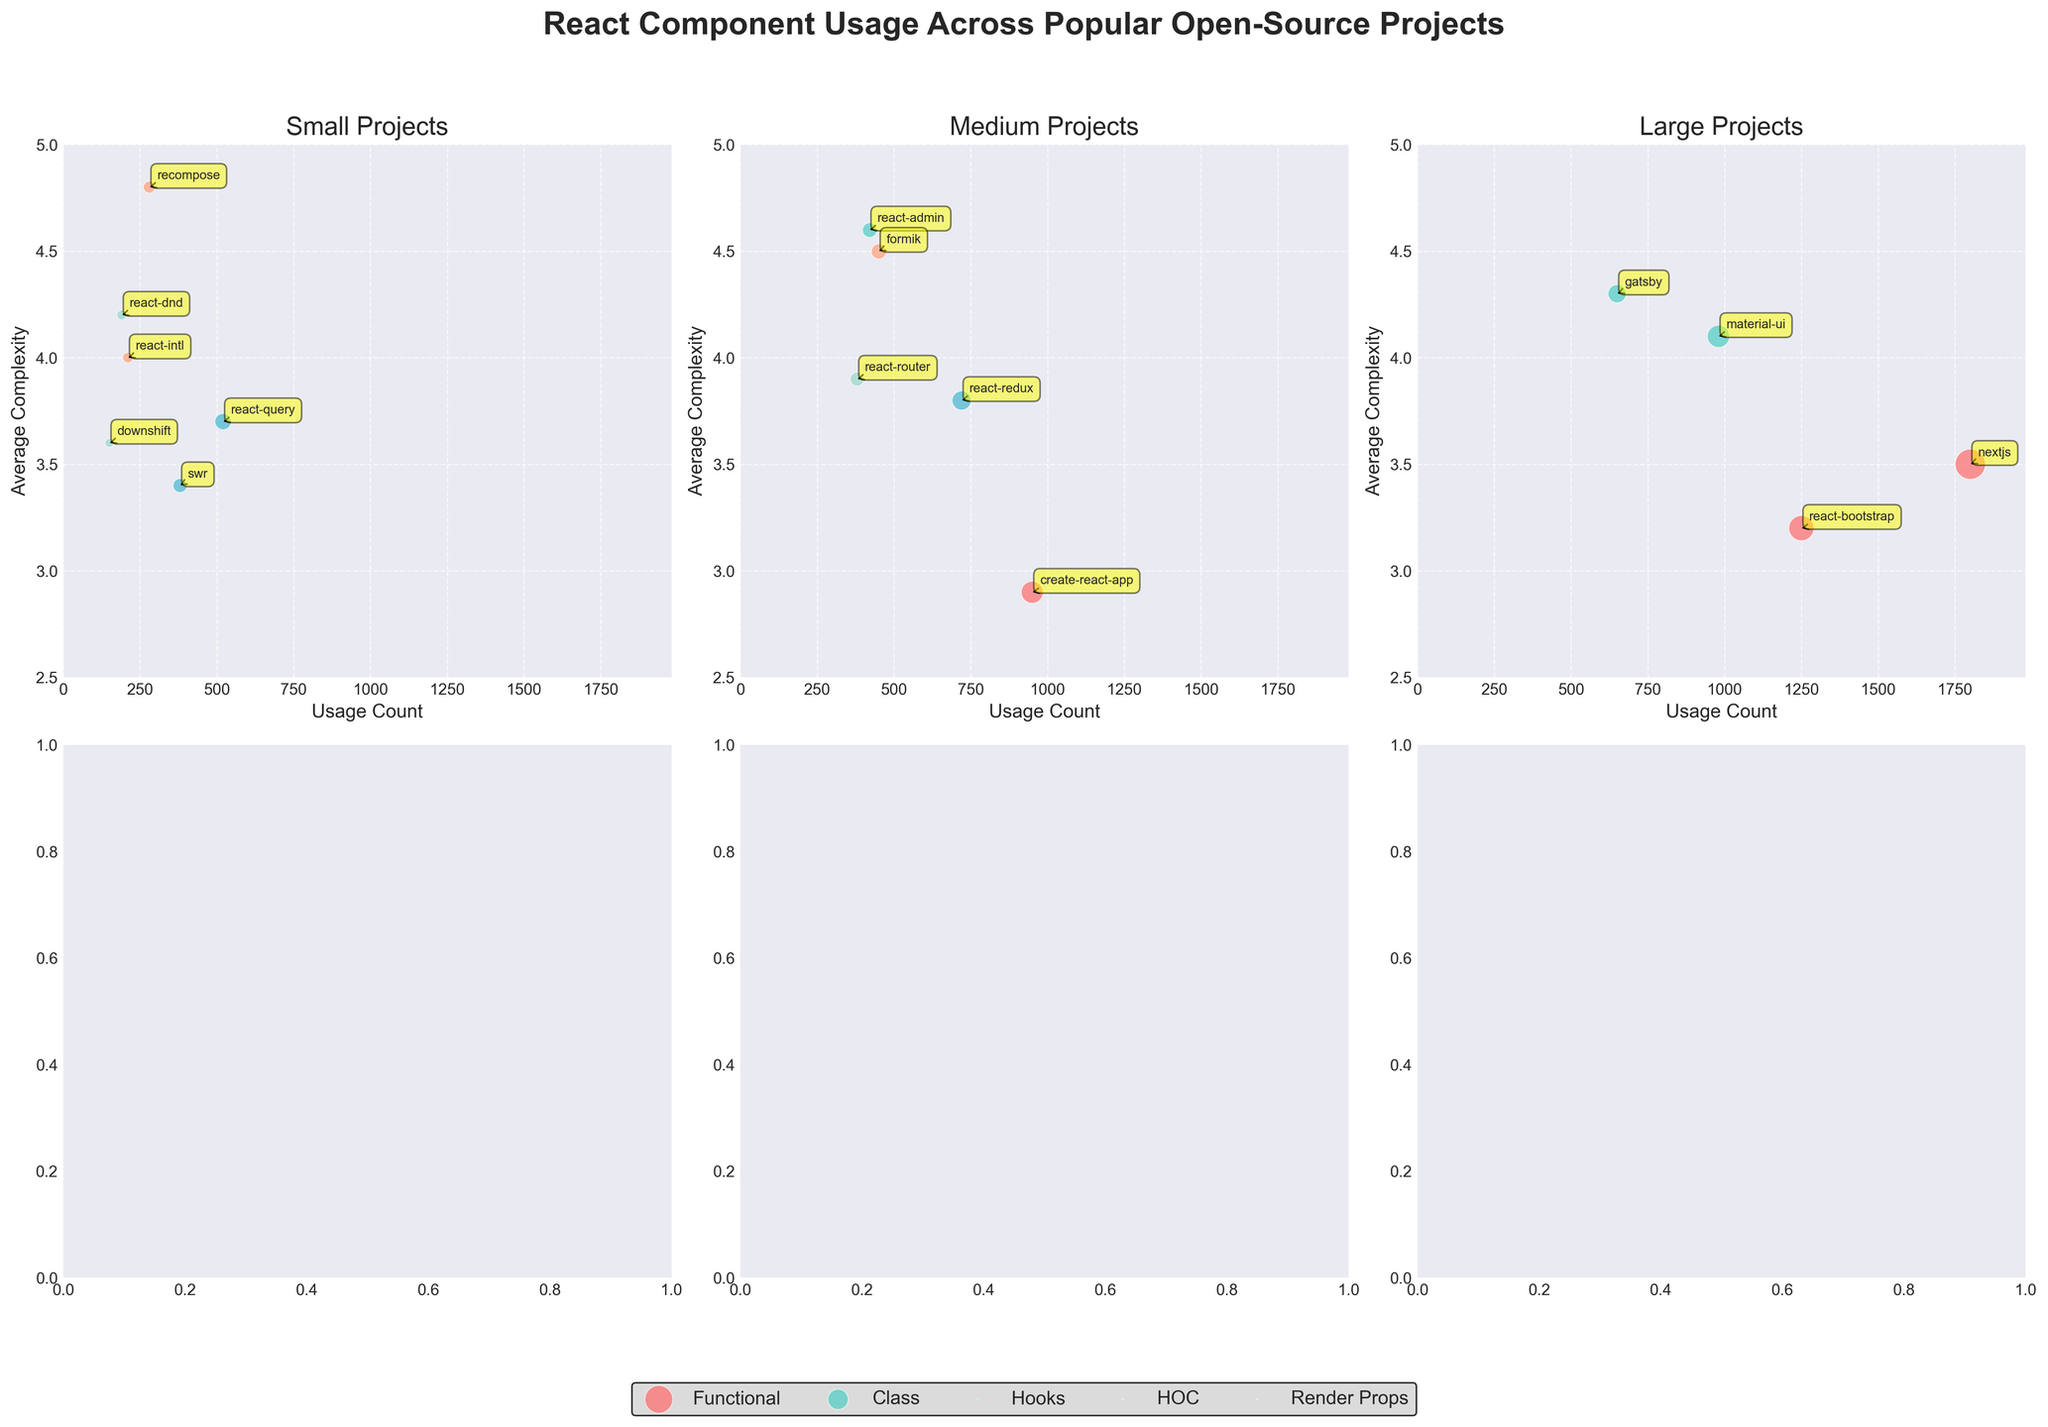What are the project sizes shown in the subplots? The subplots are categorized by project sizes: Small, Medium, and Large. This information can be found in the titles of each of the three subplots.
Answer: Small, Medium, Large How many data points are represented in the subplot for Medium projects? By counting the bubbles in the Medium projects subplot, there are 5 data points visible.
Answer: 5 Which component type has the highest usage count in Large projects? In the subplot for Large projects, the bubble with the highest x-axis value (usage count) belongs to the Functional component, represented by a red bubble.
Answer: Functional What is the average complexity of the Hooks component in Small projects? The average complexity value for the Hooks component can be read from the y-axis for the blue bubble representing Hooks in the Small projects subplot.
Answer: 3.7 Which project has the highest average complexity and in which category? The highest average complexity is observed in the Medium projects subplot for the HOC component, represented by the project "formik."
Answer: formik, Medium, HOC Compare the usage counts of Functional components between Large and Medium projects. In Large projects, the Functional components have usage counts of 1250 and 1800, while in Medium projects, the usage count is 950. By comparing these, we see that Large projects have higher usage counts.
Answer: Large projects have higher usage counts Which project has the lowest average complexity in the Medium projects category? Among the Medium projects, the Functional component represented by "create-react-app" has the lowest average complexity with a value of 2.9.
Answer: create-react-app How do the usage counts of Hooks components in Small and Medium projects compare? In the Small projects subplot, the usage count for Hooks (represented by react-query) is 520, and in the Medium projects subplot, the usage count for Hooks (represented by react-redux) is 720. Therefore, the usage count is higher in Medium projects.
Answer: Medium projects have a higher usage count Which component type in the Large projects category has the most projects associated with it? In the Large projects subplot, the Functional component appears twice (react-bootstrap and nextjs), which is the highest number of occurrences for any component type in this category.
Answer: Functional 